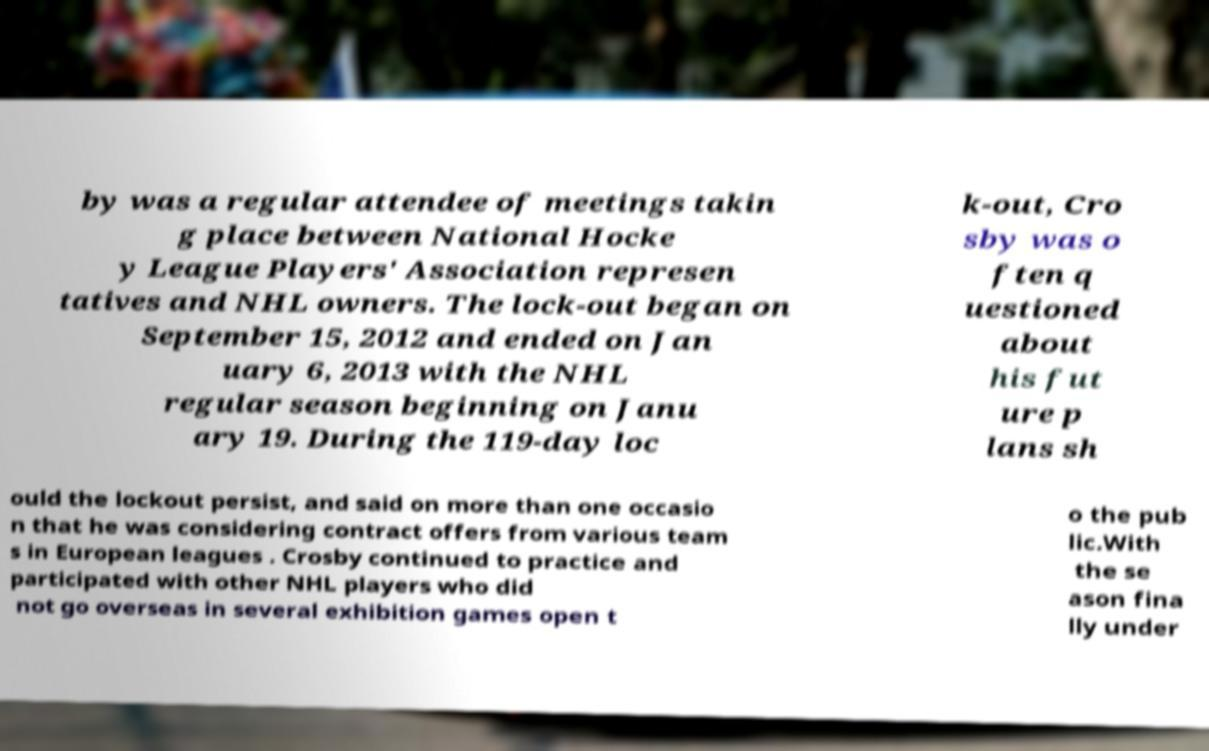What messages or text are displayed in this image? I need them in a readable, typed format. by was a regular attendee of meetings takin g place between National Hocke y League Players' Association represen tatives and NHL owners. The lock-out began on September 15, 2012 and ended on Jan uary 6, 2013 with the NHL regular season beginning on Janu ary 19. During the 119-day loc k-out, Cro sby was o ften q uestioned about his fut ure p lans sh ould the lockout persist, and said on more than one occasio n that he was considering contract offers from various team s in European leagues . Crosby continued to practice and participated with other NHL players who did not go overseas in several exhibition games open t o the pub lic.With the se ason fina lly under 